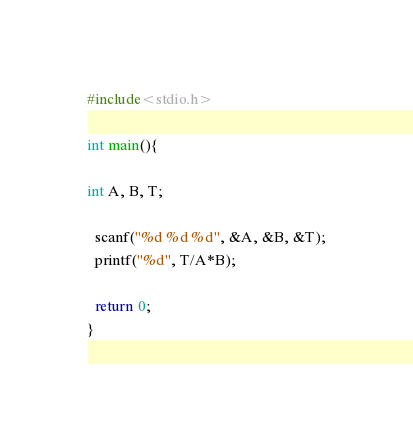<code> <loc_0><loc_0><loc_500><loc_500><_C_>#include<stdio.h>

int main(){

int A, B, T;

  scanf("%d %d %d", &A, &B, &T);
  printf("%d", T/A*B);
  
  return 0;
}</code> 